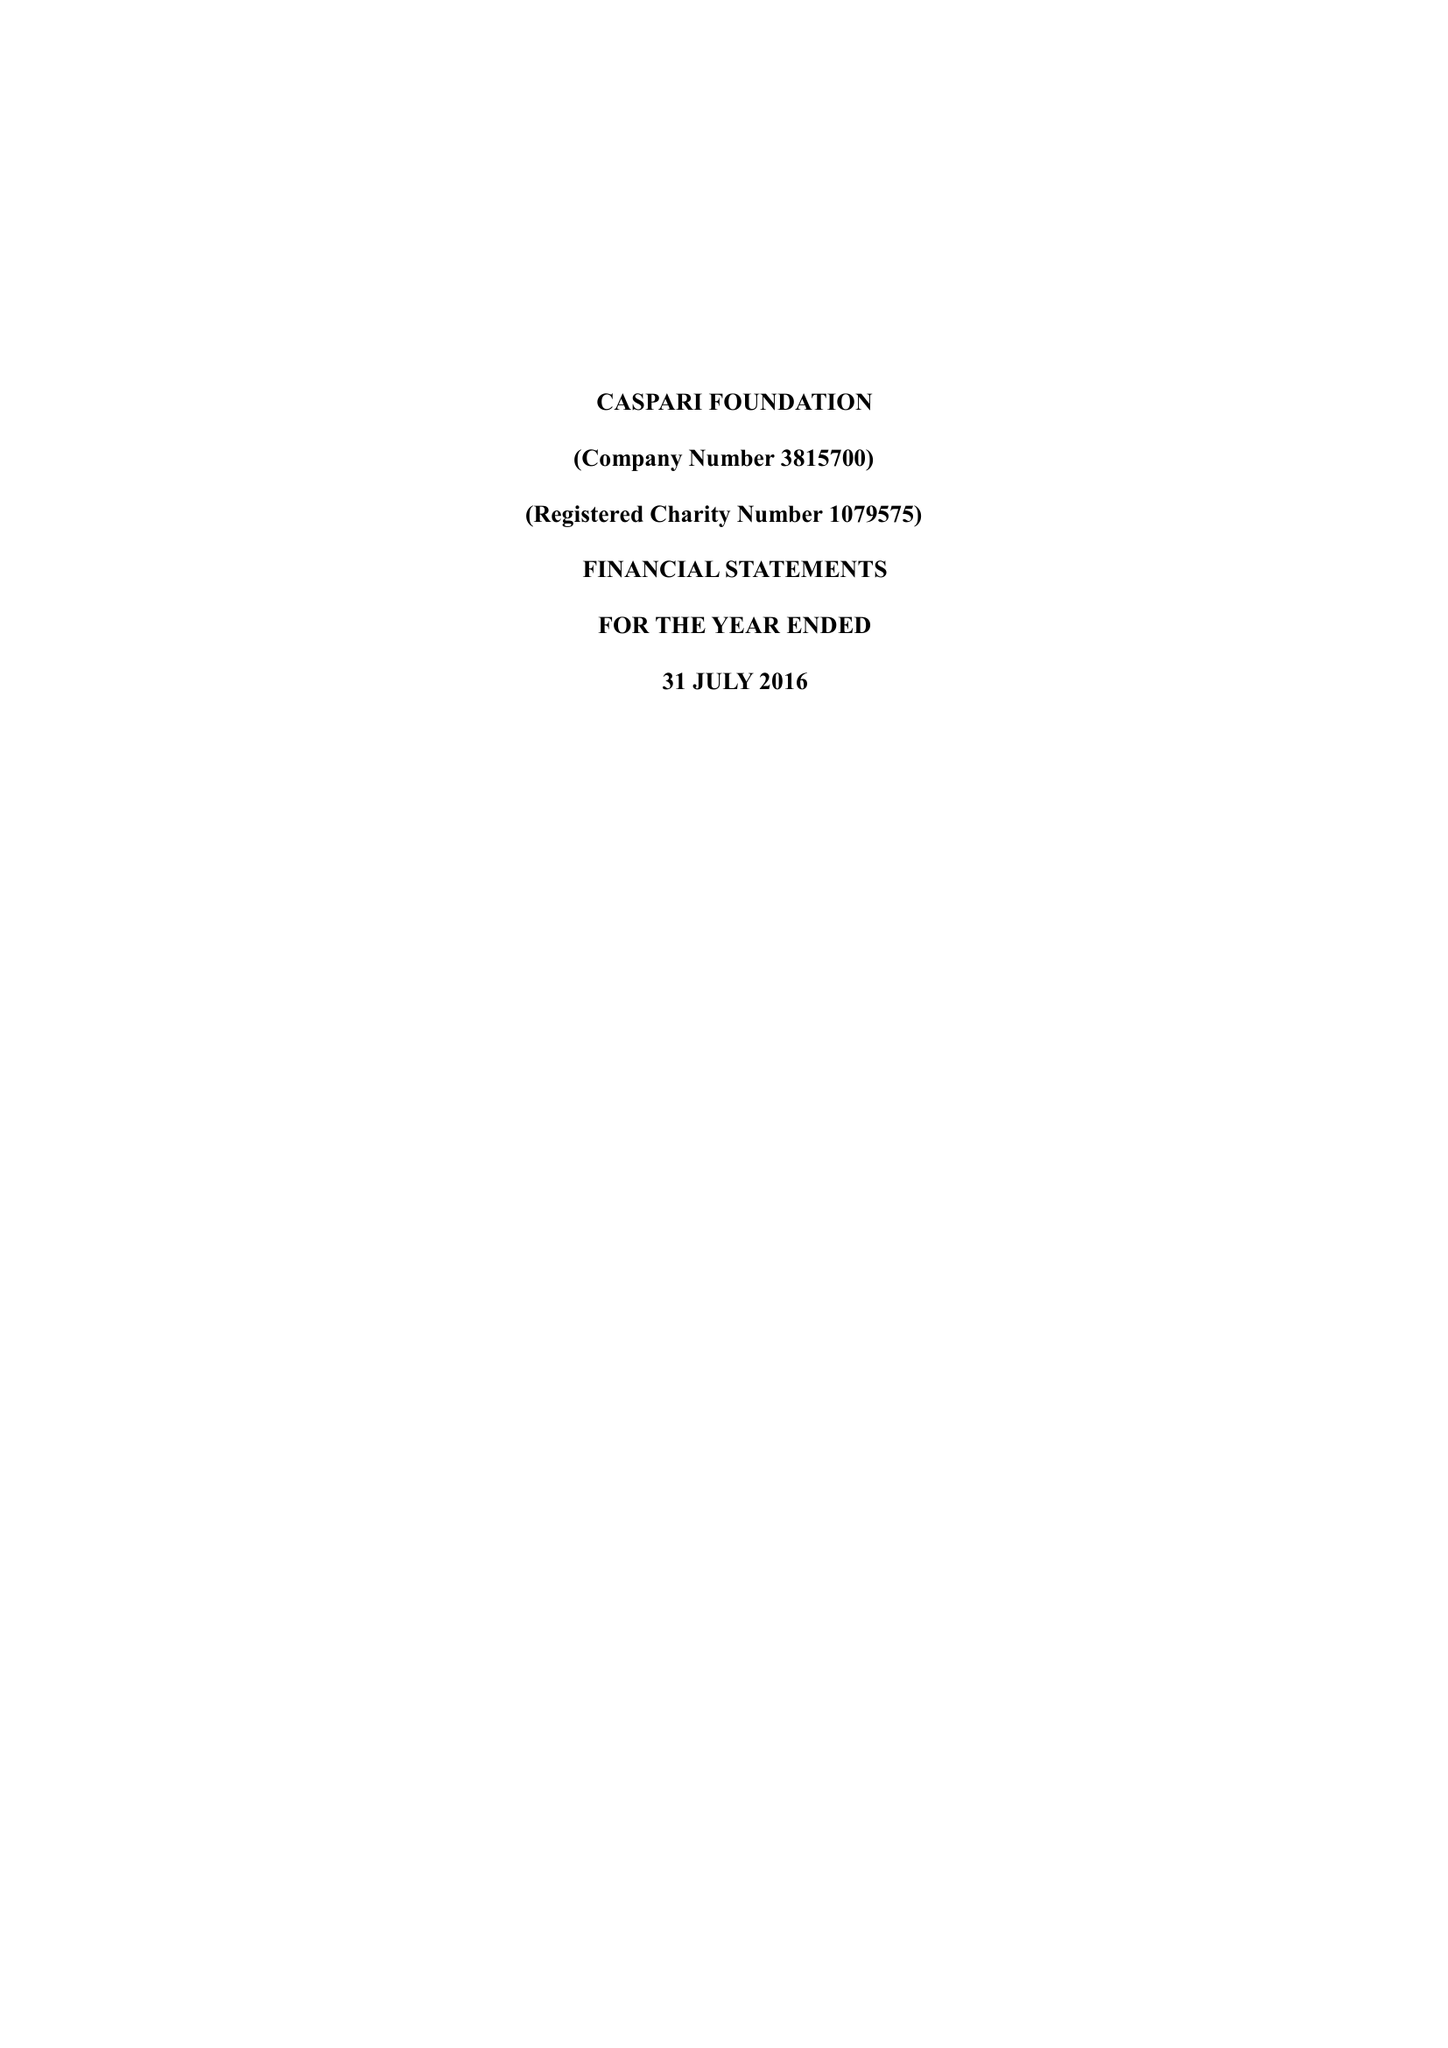What is the value for the report_date?
Answer the question using a single word or phrase. 2016-07-31 